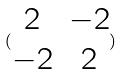Convert formula to latex. <formula><loc_0><loc_0><loc_500><loc_500>( \begin{matrix} 2 & - 2 \\ - 2 & 2 \end{matrix} )</formula> 